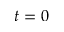Convert formula to latex. <formula><loc_0><loc_0><loc_500><loc_500>t = 0</formula> 